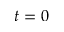Convert formula to latex. <formula><loc_0><loc_0><loc_500><loc_500>t = 0</formula> 